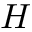<formula> <loc_0><loc_0><loc_500><loc_500>H</formula> 